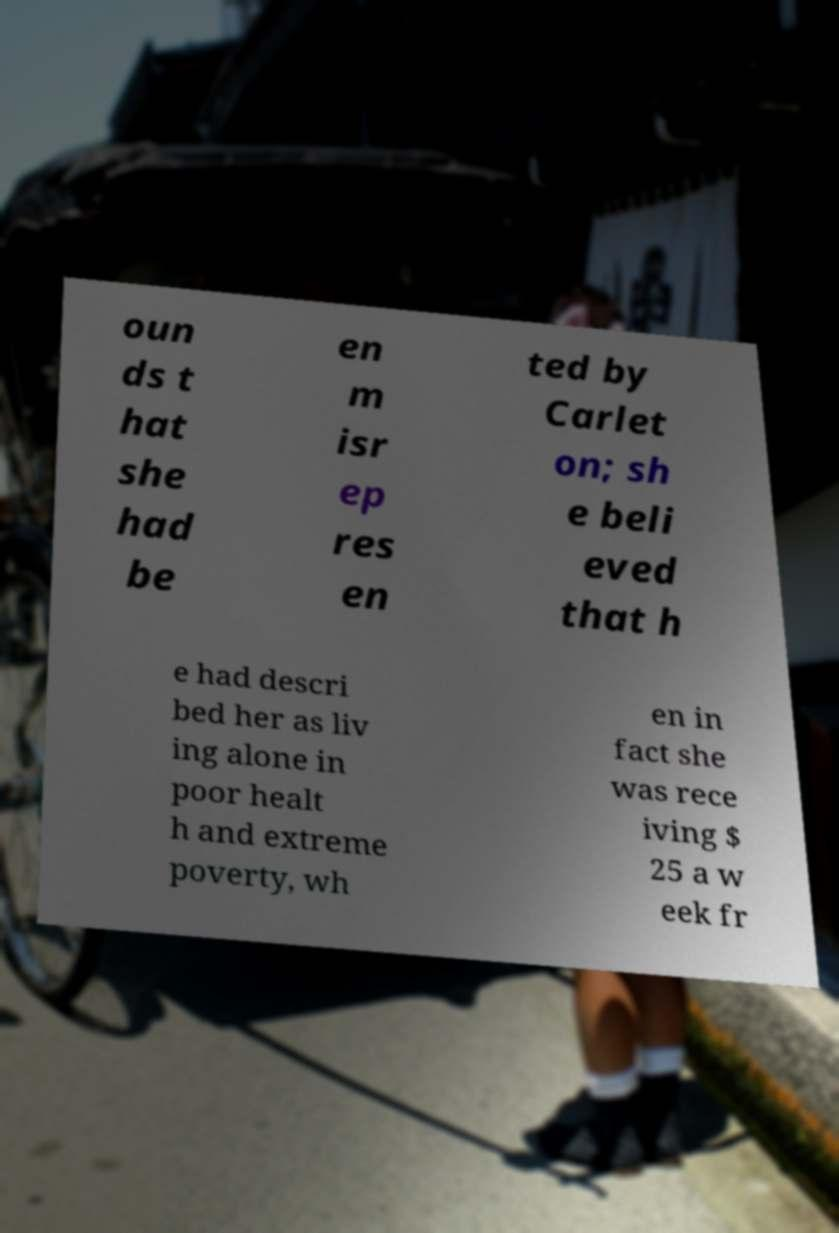Please identify and transcribe the text found in this image. oun ds t hat she had be en m isr ep res en ted by Carlet on; sh e beli eved that h e had descri bed her as liv ing alone in poor healt h and extreme poverty, wh en in fact she was rece iving $ 25 a w eek fr 